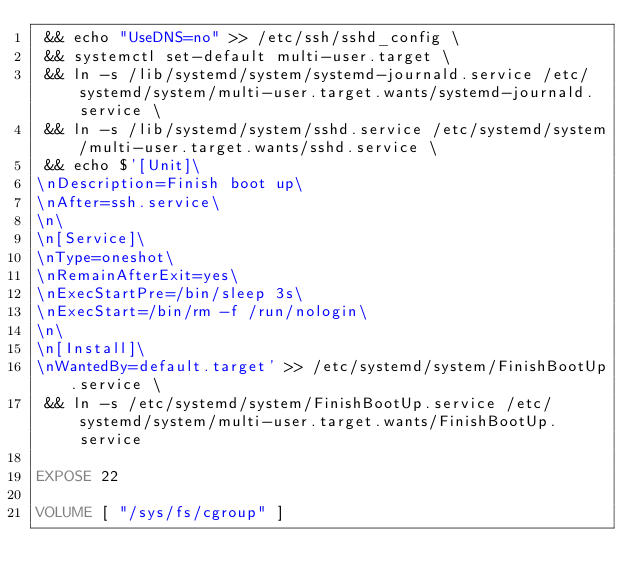Convert code to text. <code><loc_0><loc_0><loc_500><loc_500><_Dockerfile_> && echo "UseDNS=no" >> /etc/ssh/sshd_config \
 && systemctl set-default multi-user.target \
 && ln -s /lib/systemd/system/systemd-journald.service /etc/systemd/system/multi-user.target.wants/systemd-journald.service \
 && ln -s /lib/systemd/system/sshd.service /etc/systemd/system/multi-user.target.wants/sshd.service \
 && echo $'[Unit]\
\nDescription=Finish boot up\
\nAfter=ssh.service\
\n\
\n[Service]\
\nType=oneshot\
\nRemainAfterExit=yes\
\nExecStartPre=/bin/sleep 3s\
\nExecStart=/bin/rm -f /run/nologin\
\n\
\n[Install]\
\nWantedBy=default.target' >> /etc/systemd/system/FinishBootUp.service \
 && ln -s /etc/systemd/system/FinishBootUp.service /etc/systemd/system/multi-user.target.wants/FinishBootUp.service

EXPOSE 22

VOLUME [ "/sys/fs/cgroup" ]
</code> 